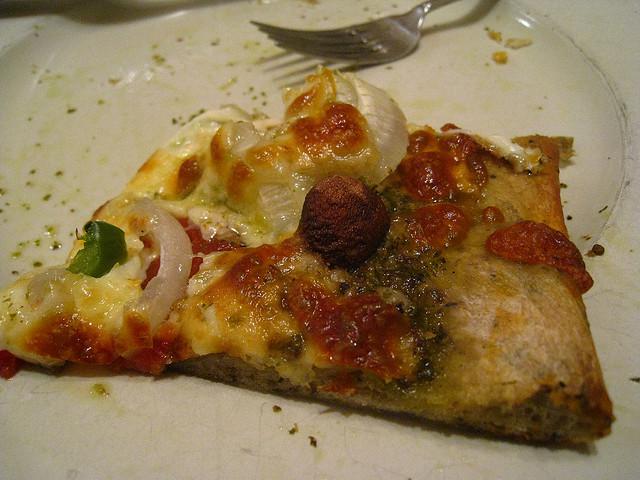Are THERE ANY ONIONS ON THIS FOOD?
Answer briefly. Yes. What is the food sitting on?
Short answer required. Plate. How many plates are here?
Short answer required. 1. Is this a healthy meal?
Write a very short answer. No. Is this a single serving?
Short answer required. Yes. Is the fork plastic or metallic?
Give a very brief answer. Metal. Where is the fork?
Write a very short answer. On plate. Is this food good?
Be succinct. Yes. Is this a $1 New York Slice?
Be succinct. No. Where are knife markings?
Short answer required. On pizza. What utensil is on the plate?
Write a very short answer. Fork. 